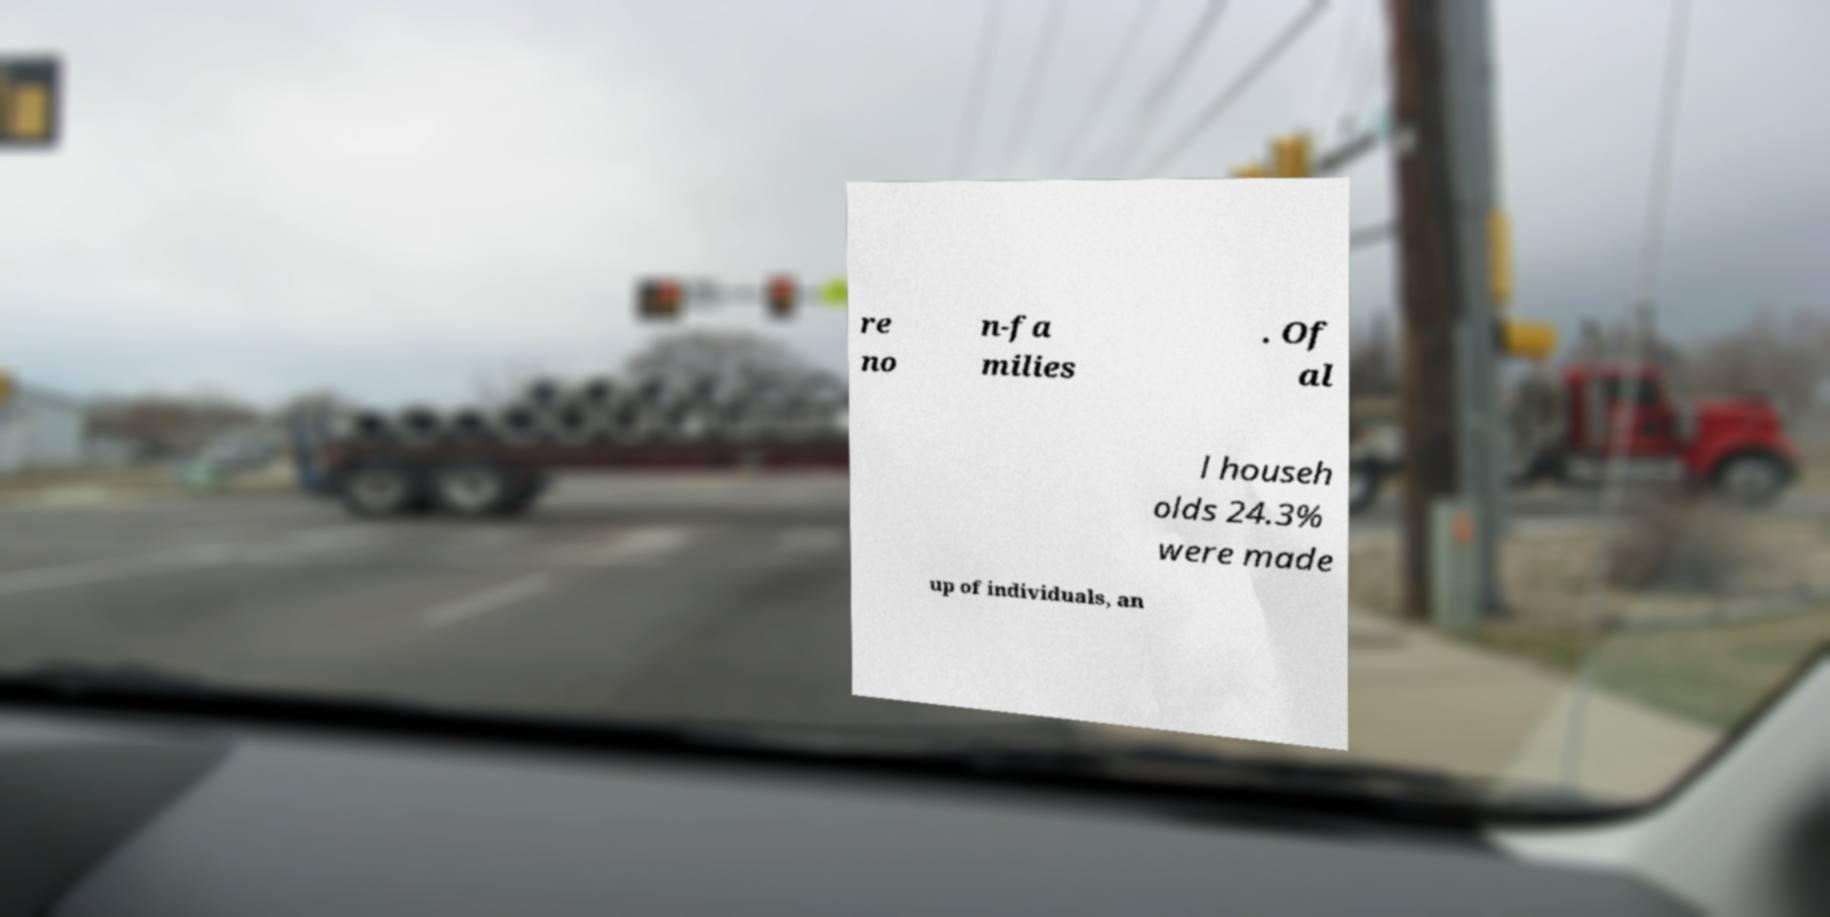Please read and relay the text visible in this image. What does it say? re no n-fa milies . Of al l househ olds 24.3% were made up of individuals, an 